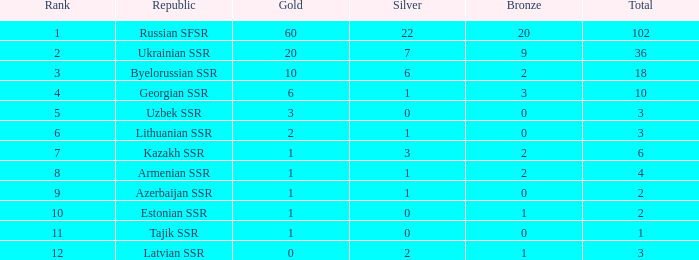What is the cumulative amount of bronzes connected to 1 silver, rankings under 6, and less than 6 golds? None. 